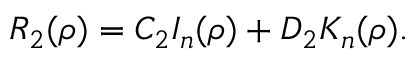<formula> <loc_0><loc_0><loc_500><loc_500>R _ { 2 } ( \rho ) = C _ { 2 } I _ { n } ( \rho ) + D _ { 2 } K _ { n } ( \rho ) .</formula> 